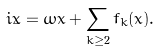Convert formula to latex. <formula><loc_0><loc_0><loc_500><loc_500>i \dot { x } = \omega x + \sum _ { k \geq 2 } f _ { k } ( x ) .</formula> 